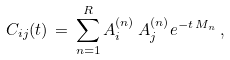Convert formula to latex. <formula><loc_0><loc_0><loc_500><loc_500>C _ { i j } ( t ) \, = \, \sum _ { n = 1 } ^ { R } A ^ { ( n ) } _ { i } \, A ^ { ( n ) } _ { j } e ^ { - t \, M _ { n } } \, ,</formula> 